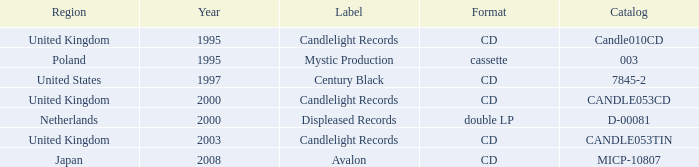What is Candlelight Records format? CD, CD, CD. 